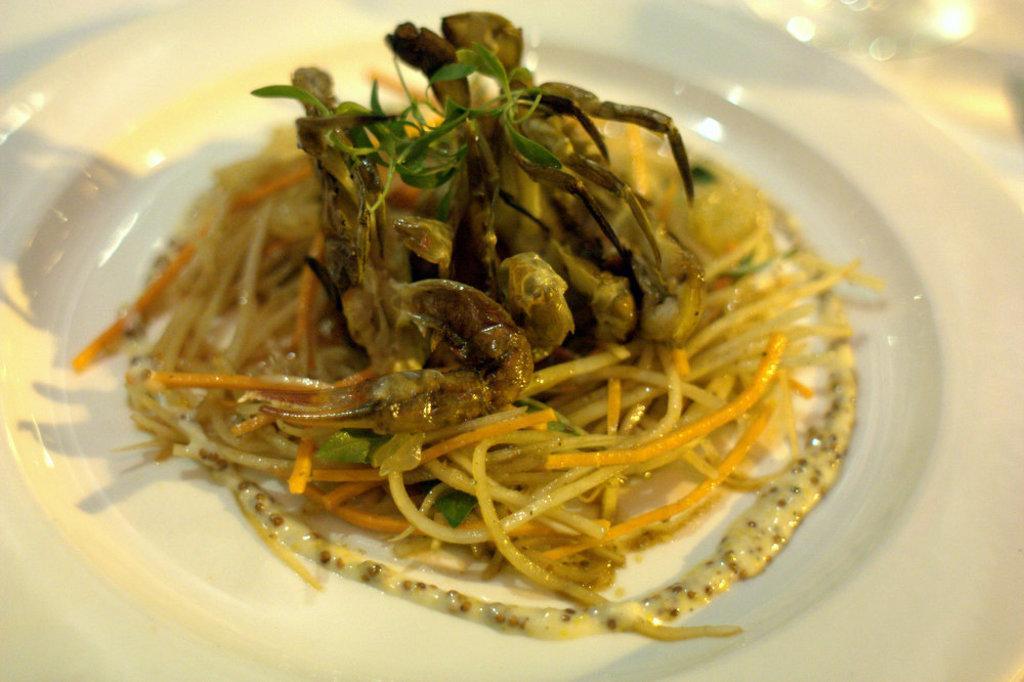Can you describe this image briefly? In this image there is a plate. In the plate there are noodles and some food stuff. 